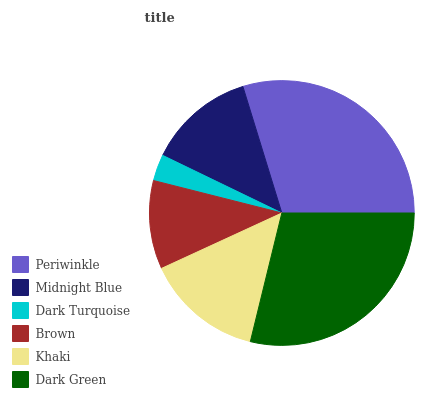Is Dark Turquoise the minimum?
Answer yes or no. Yes. Is Periwinkle the maximum?
Answer yes or no. Yes. Is Midnight Blue the minimum?
Answer yes or no. No. Is Midnight Blue the maximum?
Answer yes or no. No. Is Periwinkle greater than Midnight Blue?
Answer yes or no. Yes. Is Midnight Blue less than Periwinkle?
Answer yes or no. Yes. Is Midnight Blue greater than Periwinkle?
Answer yes or no. No. Is Periwinkle less than Midnight Blue?
Answer yes or no. No. Is Khaki the high median?
Answer yes or no. Yes. Is Midnight Blue the low median?
Answer yes or no. Yes. Is Periwinkle the high median?
Answer yes or no. No. Is Periwinkle the low median?
Answer yes or no. No. 